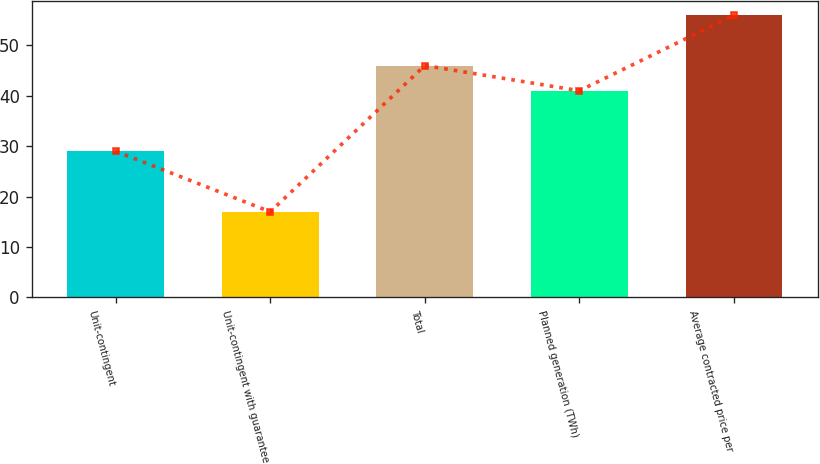<chart> <loc_0><loc_0><loc_500><loc_500><bar_chart><fcel>Unit-contingent<fcel>Unit-contingent with guarantee<fcel>Total<fcel>Planned generation (TWh)<fcel>Average contracted price per<nl><fcel>29<fcel>17<fcel>46<fcel>41<fcel>56<nl></chart> 